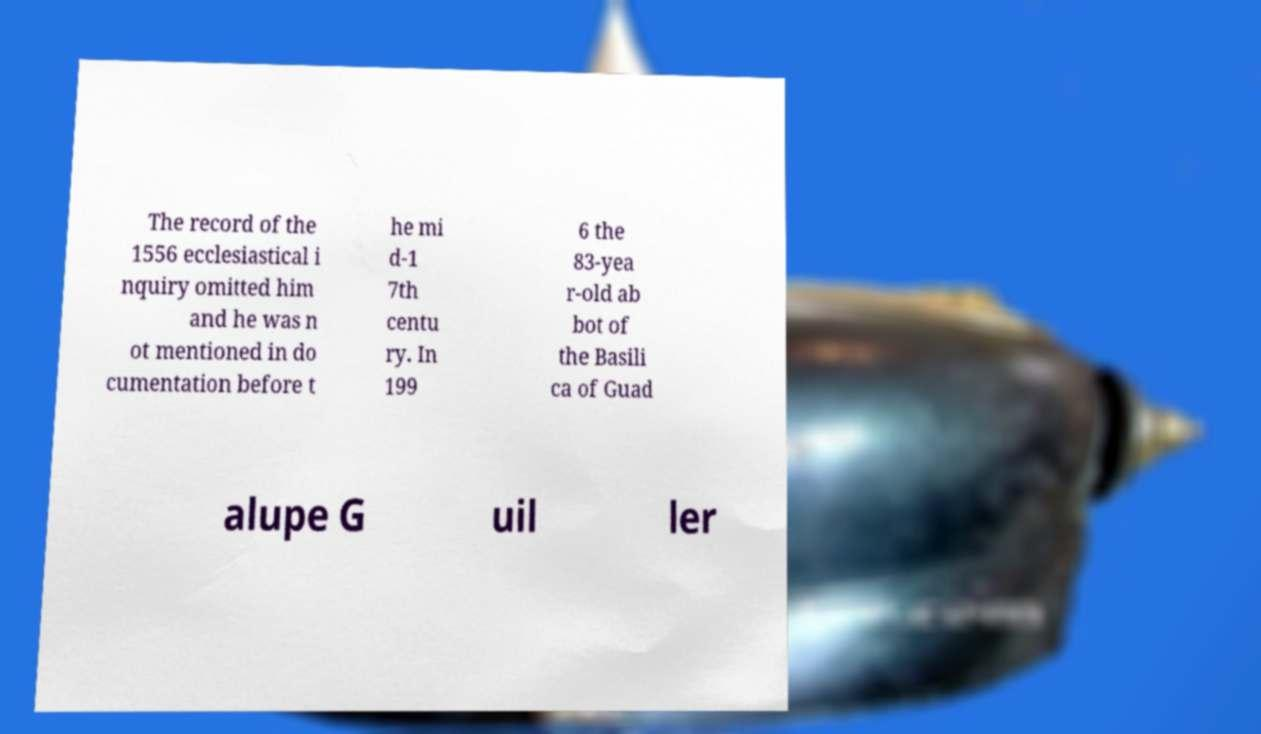I need the written content from this picture converted into text. Can you do that? The record of the 1556 ecclesiastical i nquiry omitted him and he was n ot mentioned in do cumentation before t he mi d-1 7th centu ry. In 199 6 the 83-yea r-old ab bot of the Basili ca of Guad alupe G uil ler 